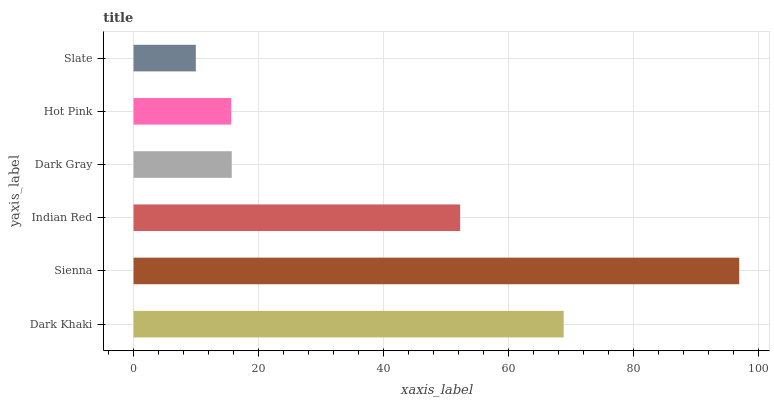Is Slate the minimum?
Answer yes or no. Yes. Is Sienna the maximum?
Answer yes or no. Yes. Is Indian Red the minimum?
Answer yes or no. No. Is Indian Red the maximum?
Answer yes or no. No. Is Sienna greater than Indian Red?
Answer yes or no. Yes. Is Indian Red less than Sienna?
Answer yes or no. Yes. Is Indian Red greater than Sienna?
Answer yes or no. No. Is Sienna less than Indian Red?
Answer yes or no. No. Is Indian Red the high median?
Answer yes or no. Yes. Is Dark Gray the low median?
Answer yes or no. Yes. Is Dark Khaki the high median?
Answer yes or no. No. Is Hot Pink the low median?
Answer yes or no. No. 